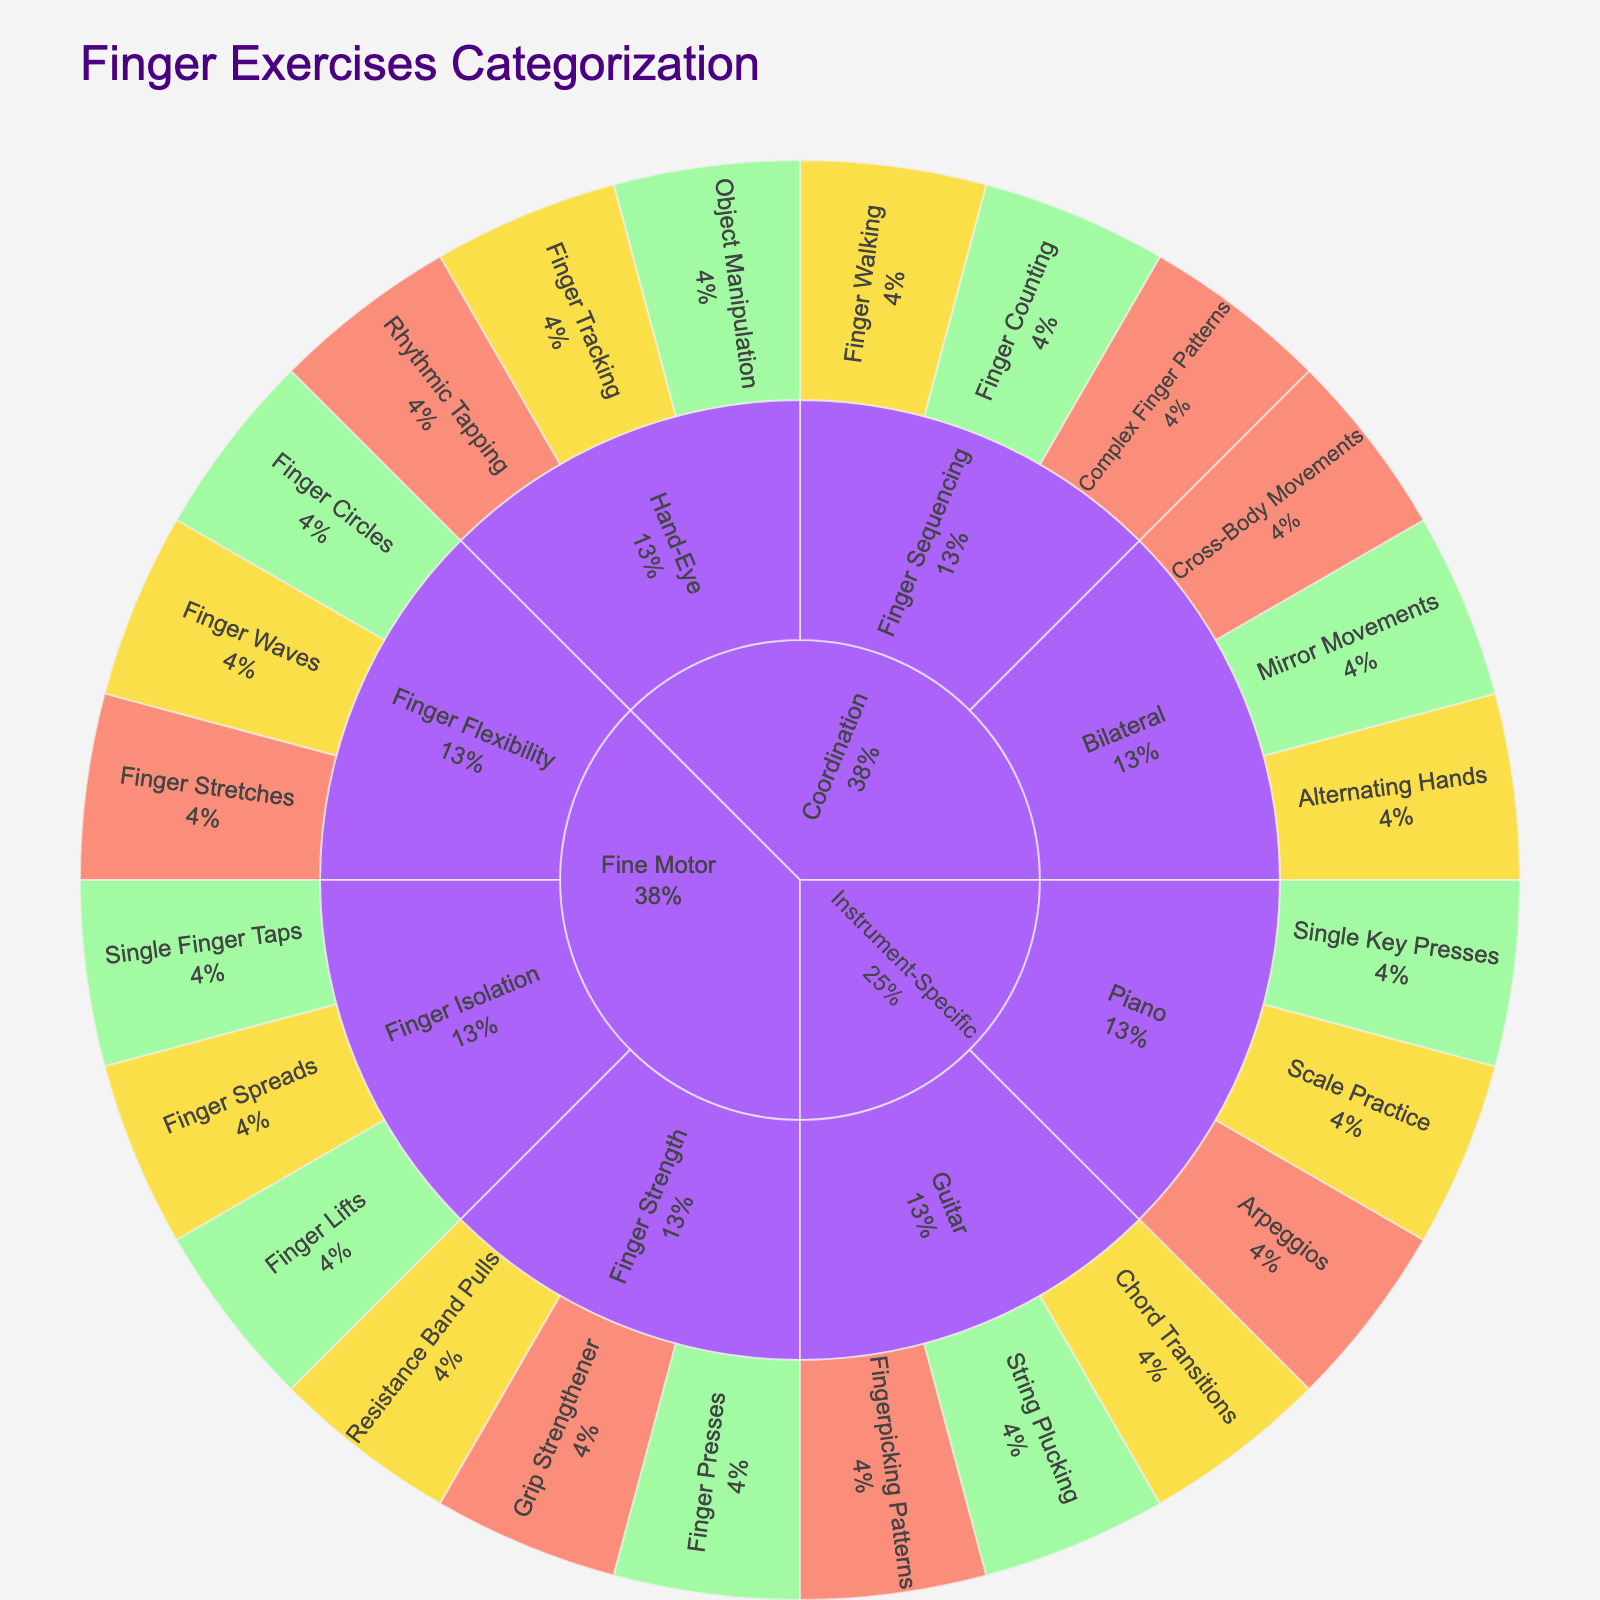What are the main categories of finger exercises in the sunburst plot? The main categories can be found in the outermost ring of the sunburst plot. They represent the highest level of division in the data. In this figure, the main categories are 'Fine Motor,' 'Coordination,' and 'Instrument-Specific.'
Answer: Fine Motor, Coordination, Instrument-Specific Which category has the most exercises labeled as 'Hard'? To answer this, locate the exercises with the 'Hard' difficulty color, then identify the category they belong to. 'Fine Motor' has the exercises 'Finger Stretches' and 'Grip Strengthener,' 'Coordination' has the exercises 'Complex Finger Patterns,' 'Rhythmic Tapping,' and 'Cross-Body Movements,' and 'Instrument-Specific' has 'Fingerpicking Patterns' and 'Arpeggios.'
Answer: Coordination How many exercises are categorized under 'Fine Motor'? To find this, you need to count all the exercises under the 'Fine Motor' category. In the plot, these are 'Single Finger Taps,' 'Finger Lifts,' 'Finger Spreads,' 'Finger Circles,' 'Finger Waves,' 'Finger Stretches,' 'Finger Presses,' 'Resistance Band Pulls,' and 'Grip Strengthener.'
Answer: Nine What is the difficulty level of 'Scale Practice' in the 'Piano' subcategory? To find the difficulty level of 'Scale Practice,' locate it within the 'Instrument-Specific' category, then look at the 'Piano' subcategory. 'Scale Practice' corresponds to the 'Medium' color code.
Answer: Medium Which exercise under 'Finger Sequencing' is of 'Hard' difficulty? Locate the 'Finger Sequencing' subcategory under 'Coordination,' then find the exercise labeled with the 'Hard' difficulty color. 'Complex Finger Patterns' is the exercise with this label.
Answer: Complex Finger Patterns Compare the number of 'Easy' exercises in 'Hand-Eye' with those in 'Bilateral' subcategories. Count the 'Easy' exercises in 'Hand-Eye' (which is 'Object Manipulation') and in 'Bilateral' (which is 'Mirror Movements'). Both subcategories have one 'Easy' exercise each.
Answer: Equal In the 'Guitar' subcategory, what is the ratio of 'Easy' to 'Hard' exercises? Identify the exercises in the 'Guitar' subcategory and count the number of 'Easy' and 'Hard' exercises. There is one 'Easy' exercise ('String Plucking') and one 'Hard' exercise ('Fingerpicking Patterns'). The ratio is 1:1.
Answer: 1:1 What proportion of 'Finger Flexibility' exercises are marked 'Medium'? Count the total number of exercises under 'Finger Flexibility' (which are 'Finger Circles,' 'Finger Waves,' and 'Finger Stretches') and then count the 'Medium' difficulty exercise among them. There are three exercises in total, one of which is 'Medium' ('Finger Waves'). The proportion is 1/3.
Answer: 1/3 